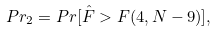Convert formula to latex. <formula><loc_0><loc_0><loc_500><loc_500>P r _ { 2 } = P r [ \hat { F } > F ( 4 , N - 9 ) ] ,</formula> 